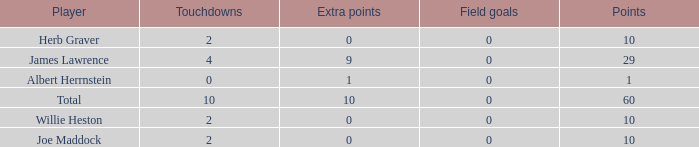What is the average number of points for players with 4 touchdowns and more than 0 field goals? None. 